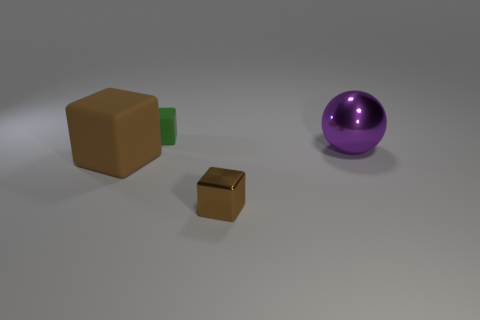Subtract all rubber cubes. How many cubes are left? 1 Subtract 2 blocks. How many blocks are left? 1 Add 2 brown rubber blocks. How many objects exist? 6 Subtract all brown blocks. How many blocks are left? 1 Add 2 tiny blue matte cubes. How many tiny blue matte cubes exist? 2 Subtract 0 cyan blocks. How many objects are left? 4 Subtract all cubes. How many objects are left? 1 Subtract all blue cubes. Subtract all purple cylinders. How many cubes are left? 3 Subtract all red balls. How many purple cubes are left? 0 Subtract all yellow metal things. Subtract all small green matte things. How many objects are left? 3 